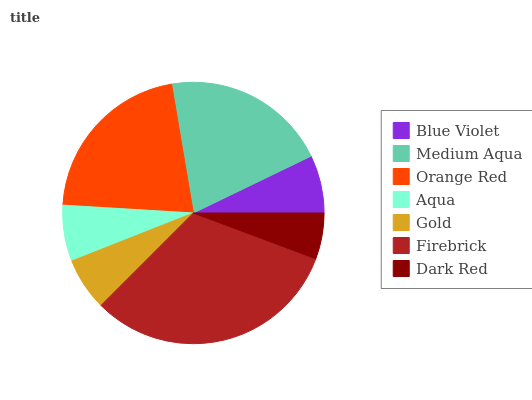Is Dark Red the minimum?
Answer yes or no. Yes. Is Firebrick the maximum?
Answer yes or no. Yes. Is Medium Aqua the minimum?
Answer yes or no. No. Is Medium Aqua the maximum?
Answer yes or no. No. Is Medium Aqua greater than Blue Violet?
Answer yes or no. Yes. Is Blue Violet less than Medium Aqua?
Answer yes or no. Yes. Is Blue Violet greater than Medium Aqua?
Answer yes or no. No. Is Medium Aqua less than Blue Violet?
Answer yes or no. No. Is Blue Violet the high median?
Answer yes or no. Yes. Is Blue Violet the low median?
Answer yes or no. Yes. Is Firebrick the high median?
Answer yes or no. No. Is Dark Red the low median?
Answer yes or no. No. 